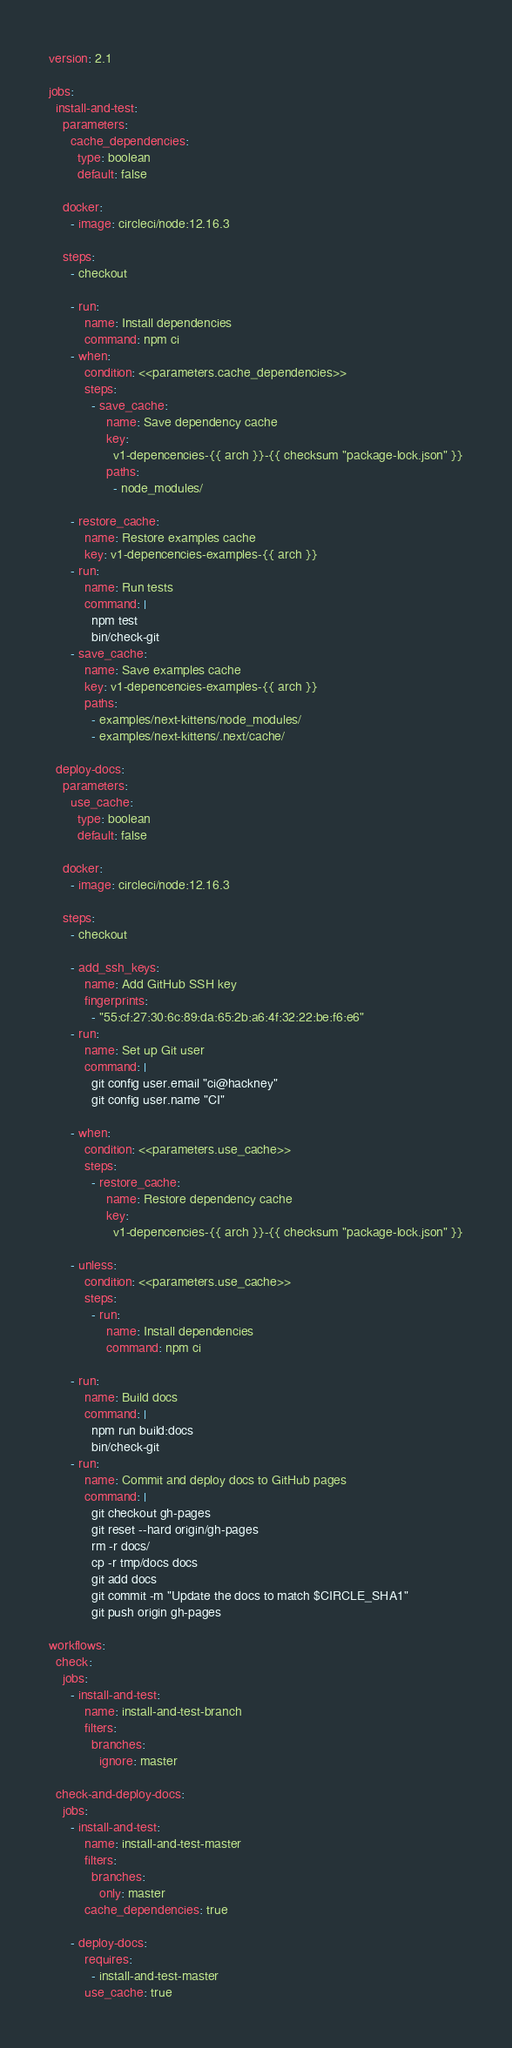Convert code to text. <code><loc_0><loc_0><loc_500><loc_500><_YAML_>version: 2.1

jobs:
  install-and-test:
    parameters:
      cache_dependencies:
        type: boolean
        default: false

    docker:
      - image: circleci/node:12.16.3

    steps:
      - checkout

      - run:
          name: Install dependencies
          command: npm ci
      - when:
          condition: <<parameters.cache_dependencies>>
          steps:
            - save_cache:
                name: Save dependency cache
                key:
                  v1-depencencies-{{ arch }}-{{ checksum "package-lock.json" }}
                paths:
                  - node_modules/

      - restore_cache:
          name: Restore examples cache
          key: v1-depencencies-examples-{{ arch }}
      - run:
          name: Run tests
          command: |
            npm test
            bin/check-git
      - save_cache:
          name: Save examples cache
          key: v1-depencencies-examples-{{ arch }}
          paths:
            - examples/next-kittens/node_modules/
            - examples/next-kittens/.next/cache/

  deploy-docs:
    parameters:
      use_cache:
        type: boolean
        default: false

    docker:
      - image: circleci/node:12.16.3

    steps:
      - checkout

      - add_ssh_keys:
          name: Add GitHub SSH key
          fingerprints:
            - "55:cf:27:30:6c:89:da:65:2b:a6:4f:32:22:be:f6:e6"
      - run:
          name: Set up Git user
          command: |
            git config user.email "ci@hackney"
            git config user.name "CI"

      - when:
          condition: <<parameters.use_cache>>
          steps:
            - restore_cache:
                name: Restore dependency cache
                key:
                  v1-depencencies-{{ arch }}-{{ checksum "package-lock.json" }}

      - unless:
          condition: <<parameters.use_cache>>
          steps:
            - run:
                name: Install dependencies
                command: npm ci

      - run:
          name: Build docs
          command: |
            npm run build:docs
            bin/check-git
      - run:
          name: Commit and deploy docs to GitHub pages
          command: |
            git checkout gh-pages
            git reset --hard origin/gh-pages
            rm -r docs/
            cp -r tmp/docs docs
            git add docs
            git commit -m "Update the docs to match $CIRCLE_SHA1"
            git push origin gh-pages

workflows:
  check:
    jobs:
      - install-and-test:
          name: install-and-test-branch
          filters:
            branches:
              ignore: master

  check-and-deploy-docs:
    jobs:
      - install-and-test:
          name: install-and-test-master
          filters:
            branches:
              only: master
          cache_dependencies: true

      - deploy-docs:
          requires:
            - install-and-test-master
          use_cache: true
</code> 